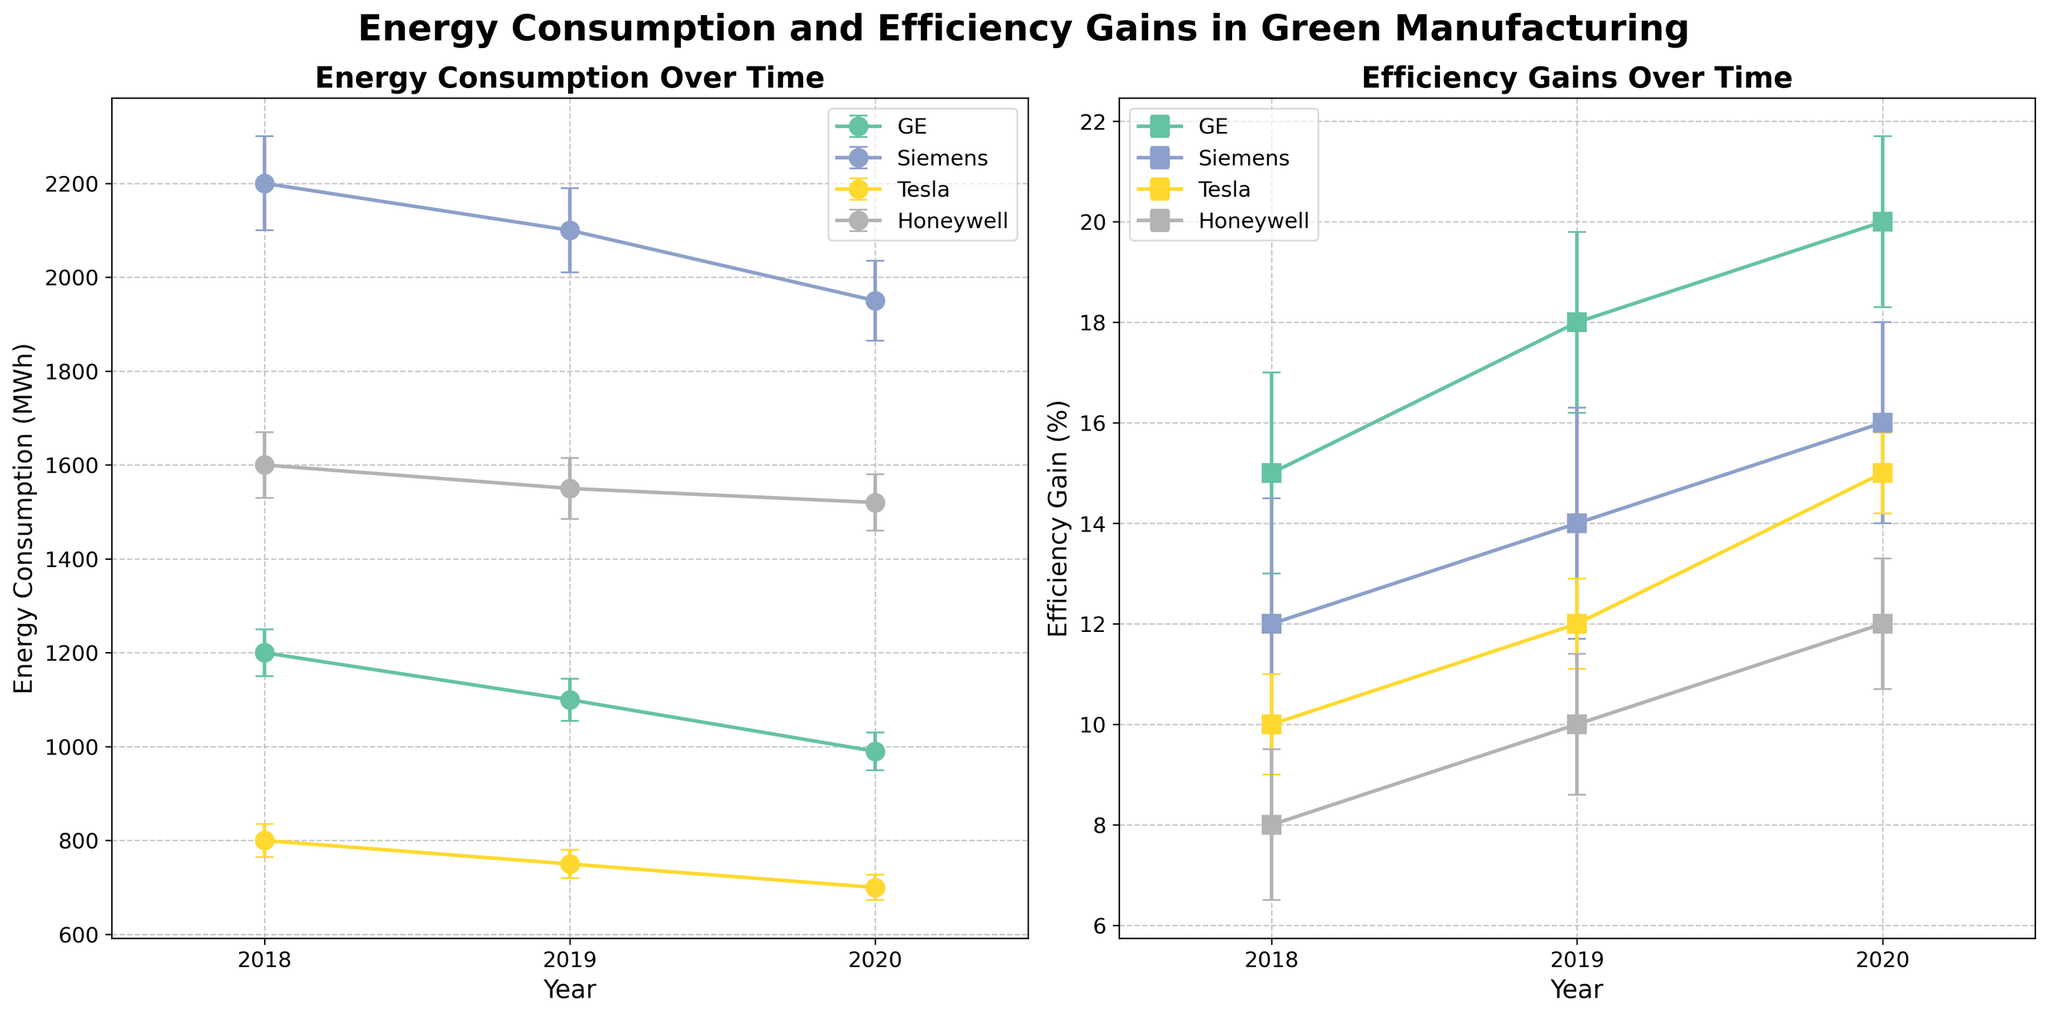What is the title of the left subplot? The title of the left subplot can be found above the subplot itself, usually summarizing its content. In this case, it reads 'Energy Consumption Over Time.'
Answer: Energy Consumption Over Time Which company has the highest energy consumption in 2020? The highest energy consumption is indicated by the vertical position of the points in the left subplot for the year 2020. Siemens has the highest energy consumption in 2020, as its point is the highest on the vertical axis at that year.
Answer: Siemens What trend can be observed in the efficiency gains for Honeywell's Smart Grids from 2018 to 2020? By following the points in the right subplot associated with Honeywell from 2018 to 2020, we see that the efficiency gains increase year by year. Specifically, the gains improve from 8% in 2018 to 12% in 2020.
Answer: Increasing How does GE's energy consumption in 2019 compare to 2020? Comparing the points for GE in 2019 and 2020 in the left subplot shows a decrease. GE's energy consumption drops from 1100 MWh in 2019 to 990 MWh in 2020.
Answer: Decreases What's the average efficiency gain for Tesla's Battery Storage over the years displayed? To find the average efficiency gain for Tesla, identify the efficiency gains from the right subplot for each year (10% in 2018, 12% in 2019, and 15% in 2020), then sum these values and divide by the number of years: (10 + 12 + 15) / 3 = 12.33%.
Answer: 12.33% Which company exhibits the highest efficiency gain in 2020? The highest efficiency gain in 2020 is indicated by the vertical position of the point in the right subplot for the year 2020. GE's Solar Panels show the highest efficiency gain at 20%.
Answer: GE What can be inferred about the relationship between energy consumption and efficiency gains for the companies over the years? Observing both subplots together, there is a general trend that when companies' energy consumption decreases, their efficiency gains increase. This is seen across various companies like GE, Siemens, and Tesla.
Answer: Inverse relationship What is the error margin for energy consumption for Tesla's Battery Storage in 2019? In the left subplot, the error margin for energy consumption is represented by the length of the error bars. The data shows Tesla's Battery Storage has an error margin of 30 MWh in 2019.
Answer: 30 MWh 